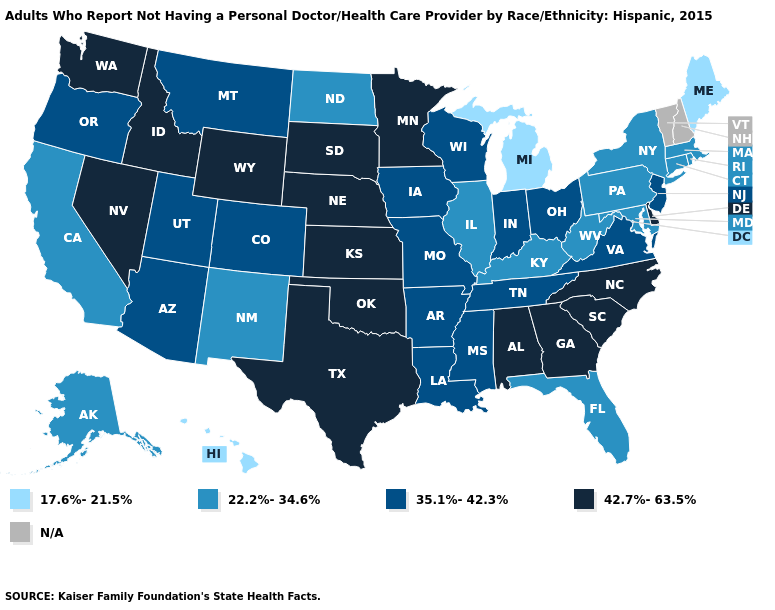Which states have the highest value in the USA?
Keep it brief. Alabama, Delaware, Georgia, Idaho, Kansas, Minnesota, Nebraska, Nevada, North Carolina, Oklahoma, South Carolina, South Dakota, Texas, Washington, Wyoming. What is the highest value in the Northeast ?
Write a very short answer. 35.1%-42.3%. Which states hav the highest value in the South?
Give a very brief answer. Alabama, Delaware, Georgia, North Carolina, Oklahoma, South Carolina, Texas. What is the value of Colorado?
Write a very short answer. 35.1%-42.3%. Is the legend a continuous bar?
Keep it brief. No. Name the states that have a value in the range 22.2%-34.6%?
Keep it brief. Alaska, California, Connecticut, Florida, Illinois, Kentucky, Maryland, Massachusetts, New Mexico, New York, North Dakota, Pennsylvania, Rhode Island, West Virginia. Among the states that border Massachusetts , which have the highest value?
Be succinct. Connecticut, New York, Rhode Island. Name the states that have a value in the range 22.2%-34.6%?
Concise answer only. Alaska, California, Connecticut, Florida, Illinois, Kentucky, Maryland, Massachusetts, New Mexico, New York, North Dakota, Pennsylvania, Rhode Island, West Virginia. Which states have the lowest value in the South?
Keep it brief. Florida, Kentucky, Maryland, West Virginia. Name the states that have a value in the range N/A?
Write a very short answer. New Hampshire, Vermont. What is the value of Nevada?
Concise answer only. 42.7%-63.5%. What is the value of Idaho?
Keep it brief. 42.7%-63.5%. Which states have the lowest value in the USA?
Keep it brief. Hawaii, Maine, Michigan. Name the states that have a value in the range 17.6%-21.5%?
Write a very short answer. Hawaii, Maine, Michigan. Does Delaware have the lowest value in the USA?
Keep it brief. No. 